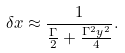<formula> <loc_0><loc_0><loc_500><loc_500>\delta x \approx \frac { 1 } { \frac { \Gamma } { 2 } + \frac { \Gamma ^ { 2 } y ^ { 2 } } { 4 } } .</formula> 